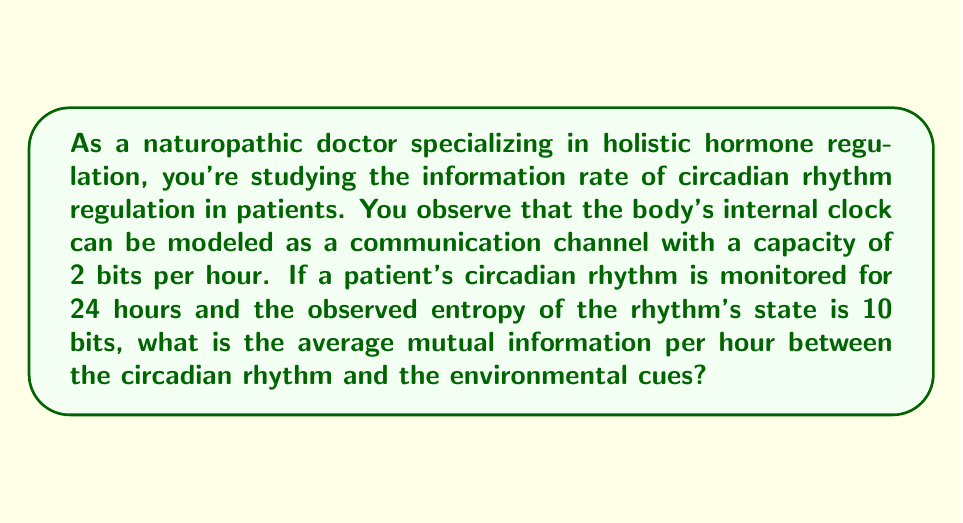Teach me how to tackle this problem. To solve this problem, we need to use concepts from information theory and apply them to the circadian rhythm regulation scenario. Let's break it down step-by-step:

1. Channel capacity: The body's internal clock is modeled as a channel with a capacity of 2 bits per hour.
   $C = 2$ bits/hour

2. Observation time: The patient's circadian rhythm is monitored for 24 hours.
   $T = 24$ hours

3. Observed entropy of the rhythm's state: 10 bits
   $H(X) = 10$ bits

4. We need to find the average mutual information per hour, which is denoted as $I(X;Y)$ in information theory.

5. The mutual information is related to the channel capacity and the entropy rate. The entropy rate is the entropy per unit time:
   Entropy rate = $H(X) / T = 10 / 24 \approx 0.4167$ bits/hour

6. In an ideal scenario, the mutual information would be equal to the channel capacity. However, the actual mutual information is constrained by the entropy rate of the source (circadian rhythm in this case).

7. The average mutual information per hour is the minimum of the channel capacity and the entropy rate:
   $I(X;Y) = \min(C, H(X)/T)$

8. Comparing the values:
   $C = 2$ bits/hour
   $H(X)/T \approx 0.4167$ bits/hour

9. Since $0.4167 < 2$, the average mutual information per hour is approximately 0.4167 bits/hour.

This result suggests that the environmental cues are providing about 0.4167 bits of information per hour to regulate the circadian rhythm, which is less than the maximum possible (channel capacity) of 2 bits per hour. This indicates that there might be room for improvement in how environmental cues are influencing the patient's circadian rhythm.
Answer: The average mutual information per hour between the circadian rhythm and the environmental cues is approximately 0.4167 bits/hour. 